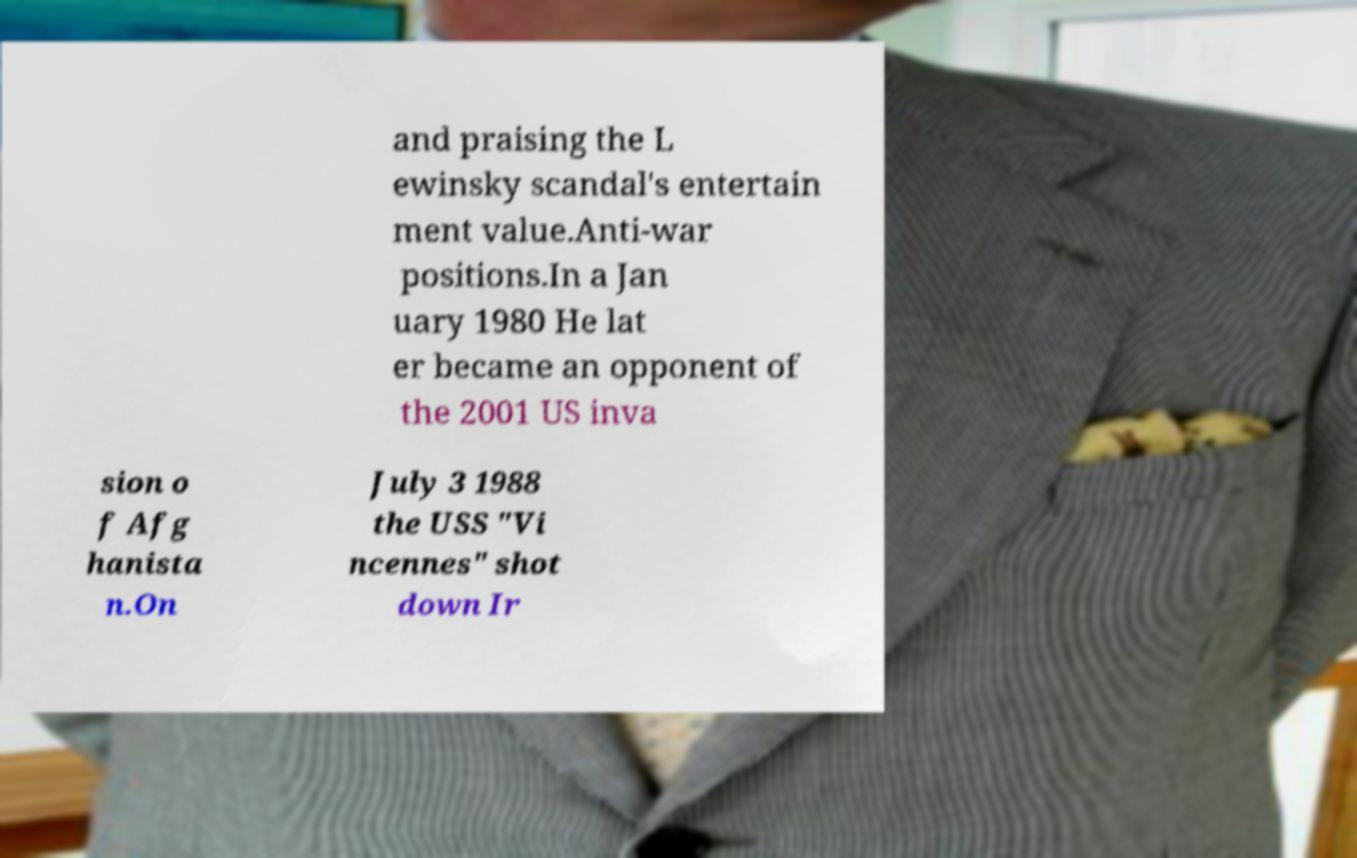I need the written content from this picture converted into text. Can you do that? and praising the L ewinsky scandal's entertain ment value.Anti-war positions.In a Jan uary 1980 He lat er became an opponent of the 2001 US inva sion o f Afg hanista n.On July 3 1988 the USS "Vi ncennes" shot down Ir 